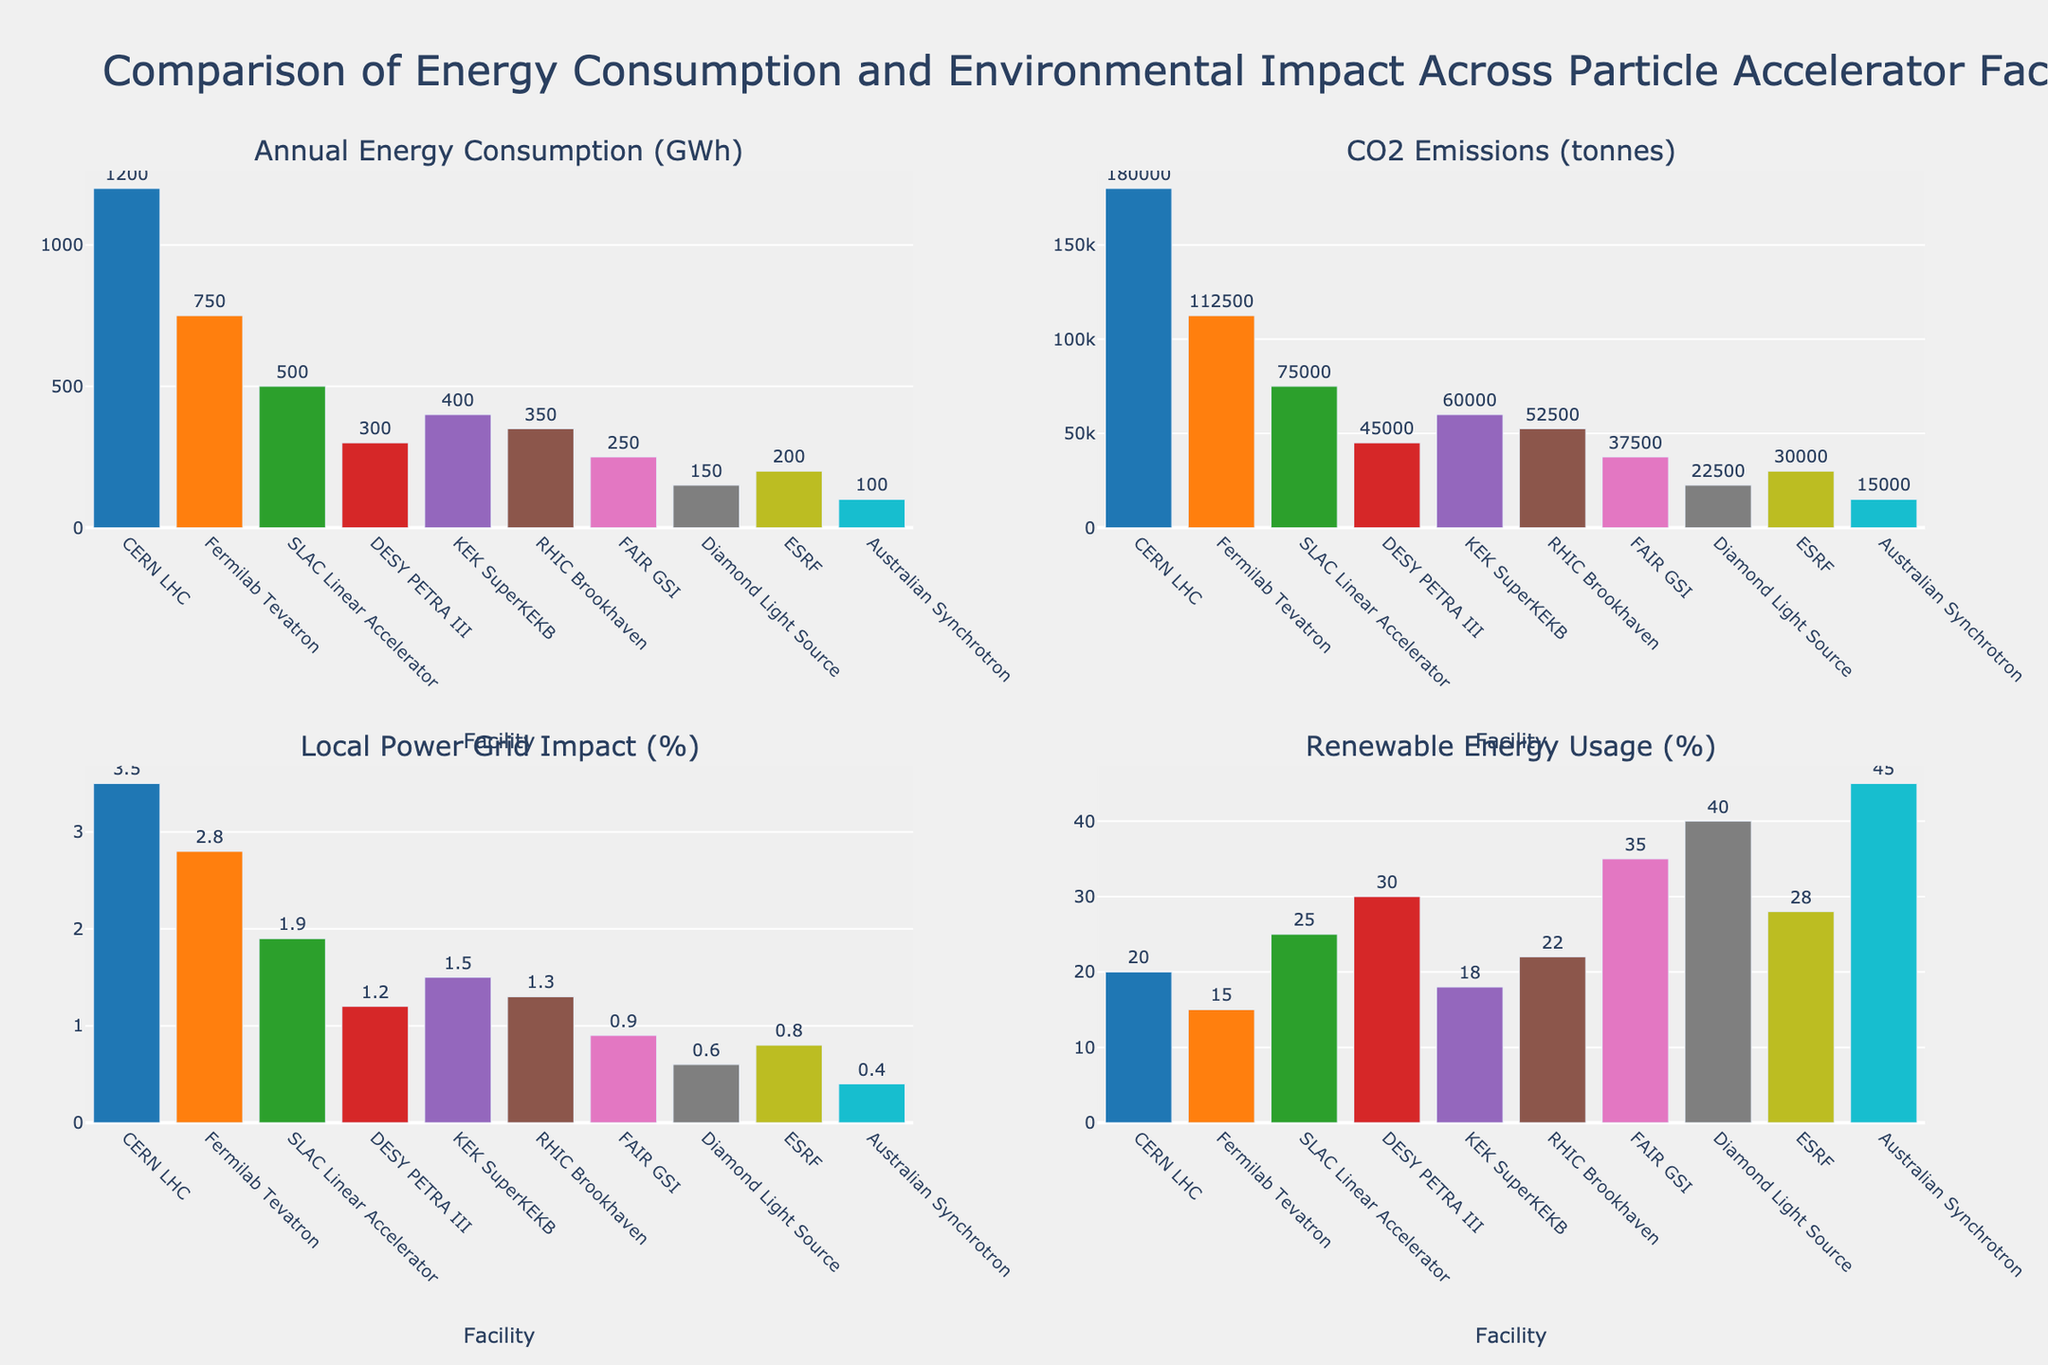What facility has the highest annual energy consumption (GWh)? The first subplot "Annual Energy Consumption (GWh)" shows the energy consumption of different facilities. The bar for CERN LHC is the tallest with an energy consumption of 1200 GWh.
Answer: CERN LHC What is the total CO2 emission from all the facilities combined? To get the total CO2 emission, sum up the CO2 emissions from each facility. The values are 180000 + 112500 + 75000 + 45000 + 60000 + 52500 + 37500 + 22500 + 30000 + 15000 = 630000 tonnes.
Answer: 630000 tonnes Which facility has the lowest local power grid impact (%)? The third subplot "Local Power Grid Impact (%)" shows the impact values. The bar for the Australian Synchrotron is the shortest with a value of 0.4%.
Answer: Australian Synchrotron How does KEK SuperKEKB's renewable energy usage (%) compare to DESY PETRA III's? In the "Renewable Energy Usage (%)" subplot, KEK SuperKEKB has 18%, and DESY PETRA III has 30%. KEK SuperKEKB’s usage is lower than DESY PETRA III by 12 percentage points.
Answer: Lower by 12 percentage points Which facility emits the most CO2 relative to its annual energy consumption? The second subplot "CO2 Emissions (tonnes)" and the first subplot "Annual Energy Consumption (GWh)" show the relevant data. The ratio of CO2 emissions to energy consumption for each facility can be calculated and compared. CERN LHC emits 180000 tonnes for 1200 GWh (150 tonnes/GWh), which is higher than others relative to their energy consumption.
Answer: CERN LHC What is the average renewable energy usage (%) across all facilities? To calculate the average, sum up the renewable energy usage values and divide by the number of facilities. The values are 20 + 15 + 25 + 30 + 18 + 22 + 35 + 40 + 28 + 45 = 278. There are 10 facilities, so 278 / 10 = 27.8.
Answer: 27.8% Compare the local power grid impact (%) of SLAC Linear Accelerator to RHIC Brookhaven. SLAC Linear Accelerator has a local power grid impact of 1.9% and RHIC Brookhaven has 1.3%. SLAC Linear Accelerator has a 0.6 percentage points higher impact than RHIC Brookhaven.
Answer: SLAC Linear Accelerator is higher by 0.6% What is the rank of Diamond Light Source in terms of annual energy consumption (GWh) from highest to lowest? By checking the "Annual Energy Consumption (GWh)" subplot, Diamond Light Source has an energy consumption of 150 GWh. From highest to lowest, the ranks would be CERN LHC (1200), Fermilab Tevatron (750), SLAC Linear Accelerator (500), KEK SuperKEKB (400), RHIC Brookhaven (350), DESY PETRA III (300), FAIR GSI (250), ESRF (200), Diamond Light Source (150), Australian Synchrotron (100). Diamond Light Source ranks 9th.
Answer: 9th 